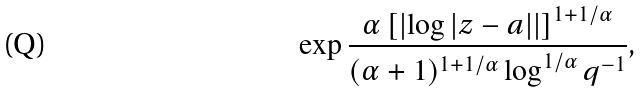<formula> <loc_0><loc_0><loc_500><loc_500>\exp \frac { \alpha \left [ \left | \log | z - a | \right | \right ] ^ { 1 + 1 / \alpha } } { ( \alpha + 1 ) ^ { 1 + 1 / \alpha } \log ^ { 1 / \alpha } q ^ { - 1 } } ,</formula> 